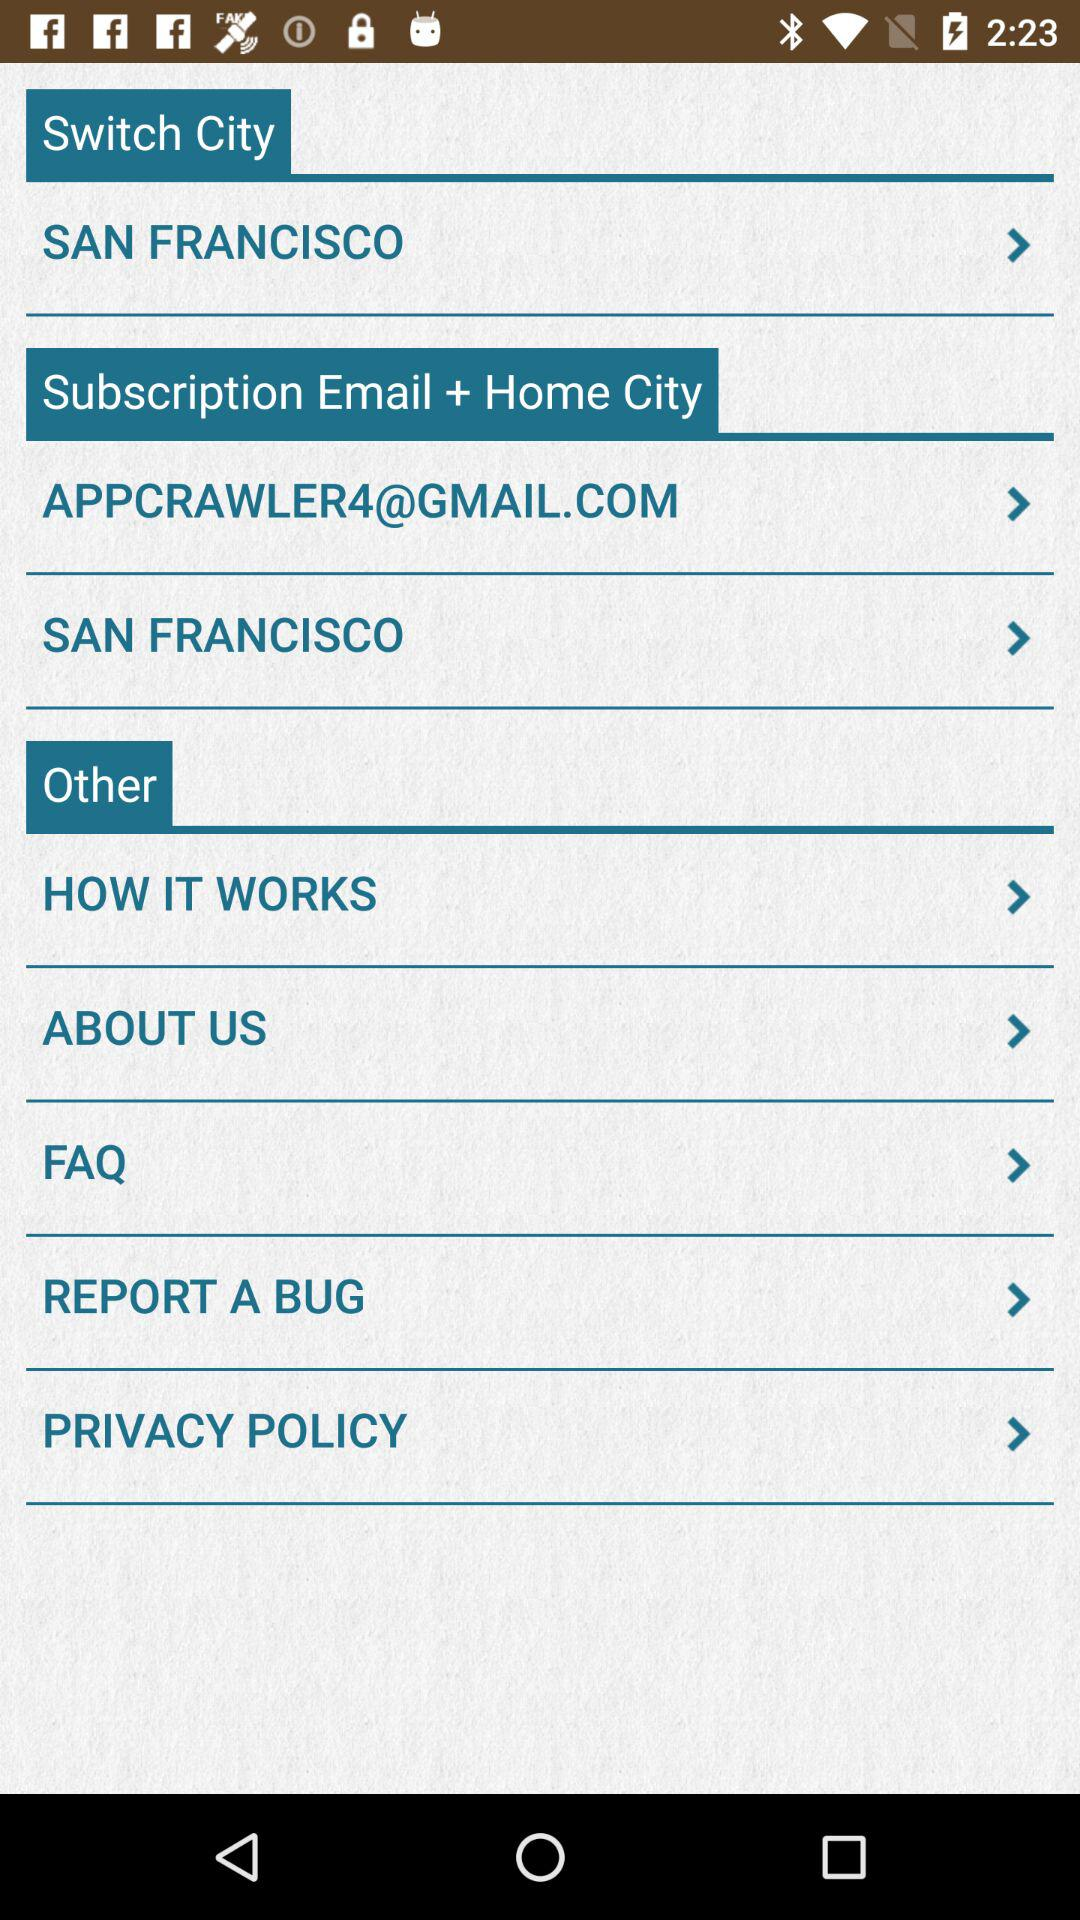What is the home city? The home city is San Francisco. 